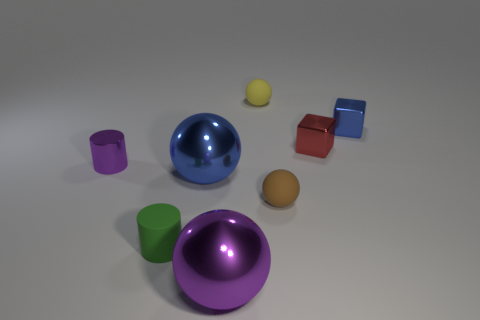What textures are visible on the objects? The spectrum of textures in this composition ranges from glossy and reflective to matte. The most noticeable contrast can be seen between the luminous sheen of the large blue sphere and the muted, non-reflective surface of the purple cylinder that lies in the foreground. Are there shadows visible around the objects? Yes, each object casts a soft-edged shadow onto the plane, contributing to a sense of depth and dimensionality in the image. 